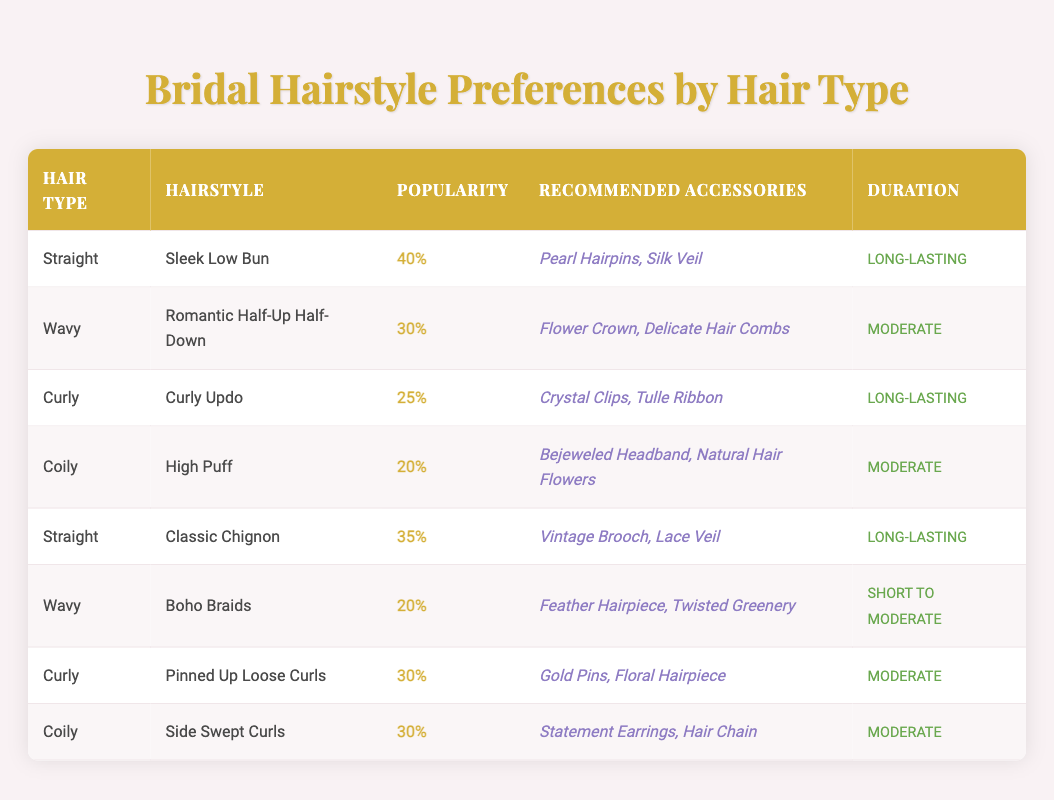What hairstyle is the most popular for straight hair? According to the table, the most popular hairstyle for straight hair is the "Sleek Low Bun," with a popularity percentage of 40.
Answer: Sleek Low Bun What is the recommended accessory for the "Pinned Up Loose Curls"? The table shows that the recommended accessories for the "Pinned Up Loose Curls" hairstyle are "Gold Pins" and "Floral Hairpiece."
Answer: Gold Pins, Floral Hairpiece Which hairstyle has the longest duration for curly hair? The table indicates that both "Curly Updo" and "Pinned Up Loose Curls" have a duration listed as "Long-lasting," but the Curly Updo has a popularity percentage of 25 compared to 30 for the Pinned Up Loose Curls, so both are equal in duration.
Answer: Both are long-lasting What percentage of the total popularity do the top two wavy hairstyles account for? The top two wavy hairstyles are "Romantic Half-Up Half-Down" (30%) and "Boho Braids" (20%). To find their combined popularity, we add 30 + 20 = 50.
Answer: 50 Is the "High Puff" hairstyle more popular than the "Romantic Half-Up Half-Down"? Looking at the table, the "High Puff" hairstyle has a popularity percentage of 20, while the "Romantic Half-Up Half-Down" has a popularity percentage of 30. Since 20 is less than 30, the answer is no.
Answer: No What is the average popularity percentage for coily hairstyles? The table lists the popularity percentages for coily hairstyles as 20% for "High Puff" and 30% for "Side Swept Curls." To find the average, we add both percentages (20 + 30 = 50) and divide by the number of hairstyles (2), yielding an average of 25%.
Answer: 25 What type of accessory is recommended for the "Sleek Low Bun"? The table reveals that the recommended accessories for the "Sleek Low Bun" include "Pearl Hairpins" and "Silk Veil."
Answer: Pearl Hairpins, Silk Veil Which hair type has the highest overall hairstyle popularity percentage? After calculating, the highest overall popularity percentage is for straight hair, with the "Sleek Low Bun" at 40% and "Classic Chignon" at 35%, totaling 75%. This is greater than any other hair type.
Answer: Straight hair Which hairstyle for wavy hair has the shortest duration? Referring to the table, the "Boho Braids" hairstyle is listed with a duration of "Short to Moderate," which is shorter than the other styles for wavy hair.
Answer: Boho Braids 